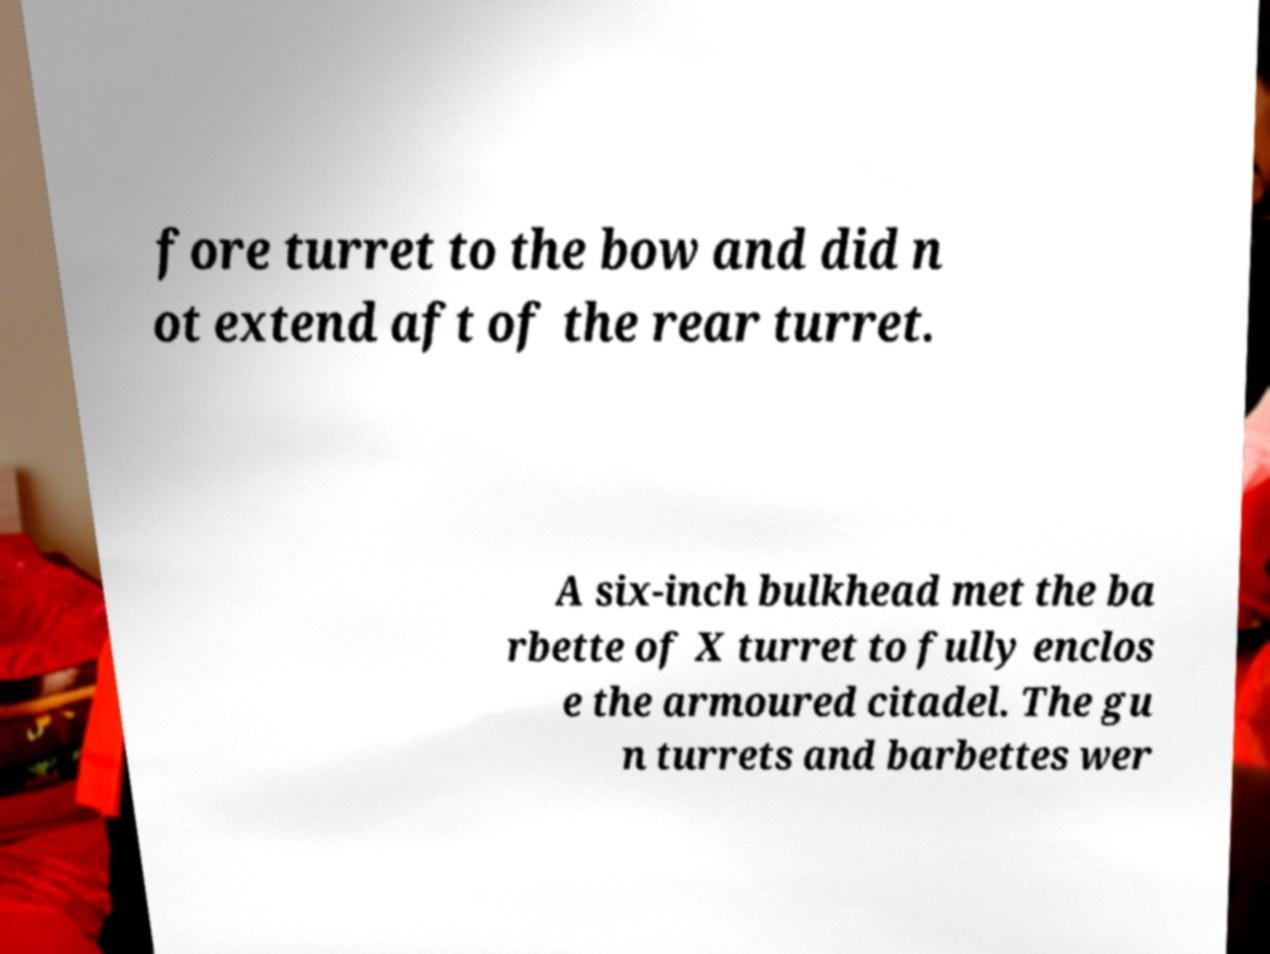Could you extract and type out the text from this image? fore turret to the bow and did n ot extend aft of the rear turret. A six-inch bulkhead met the ba rbette of X turret to fully enclos e the armoured citadel. The gu n turrets and barbettes wer 